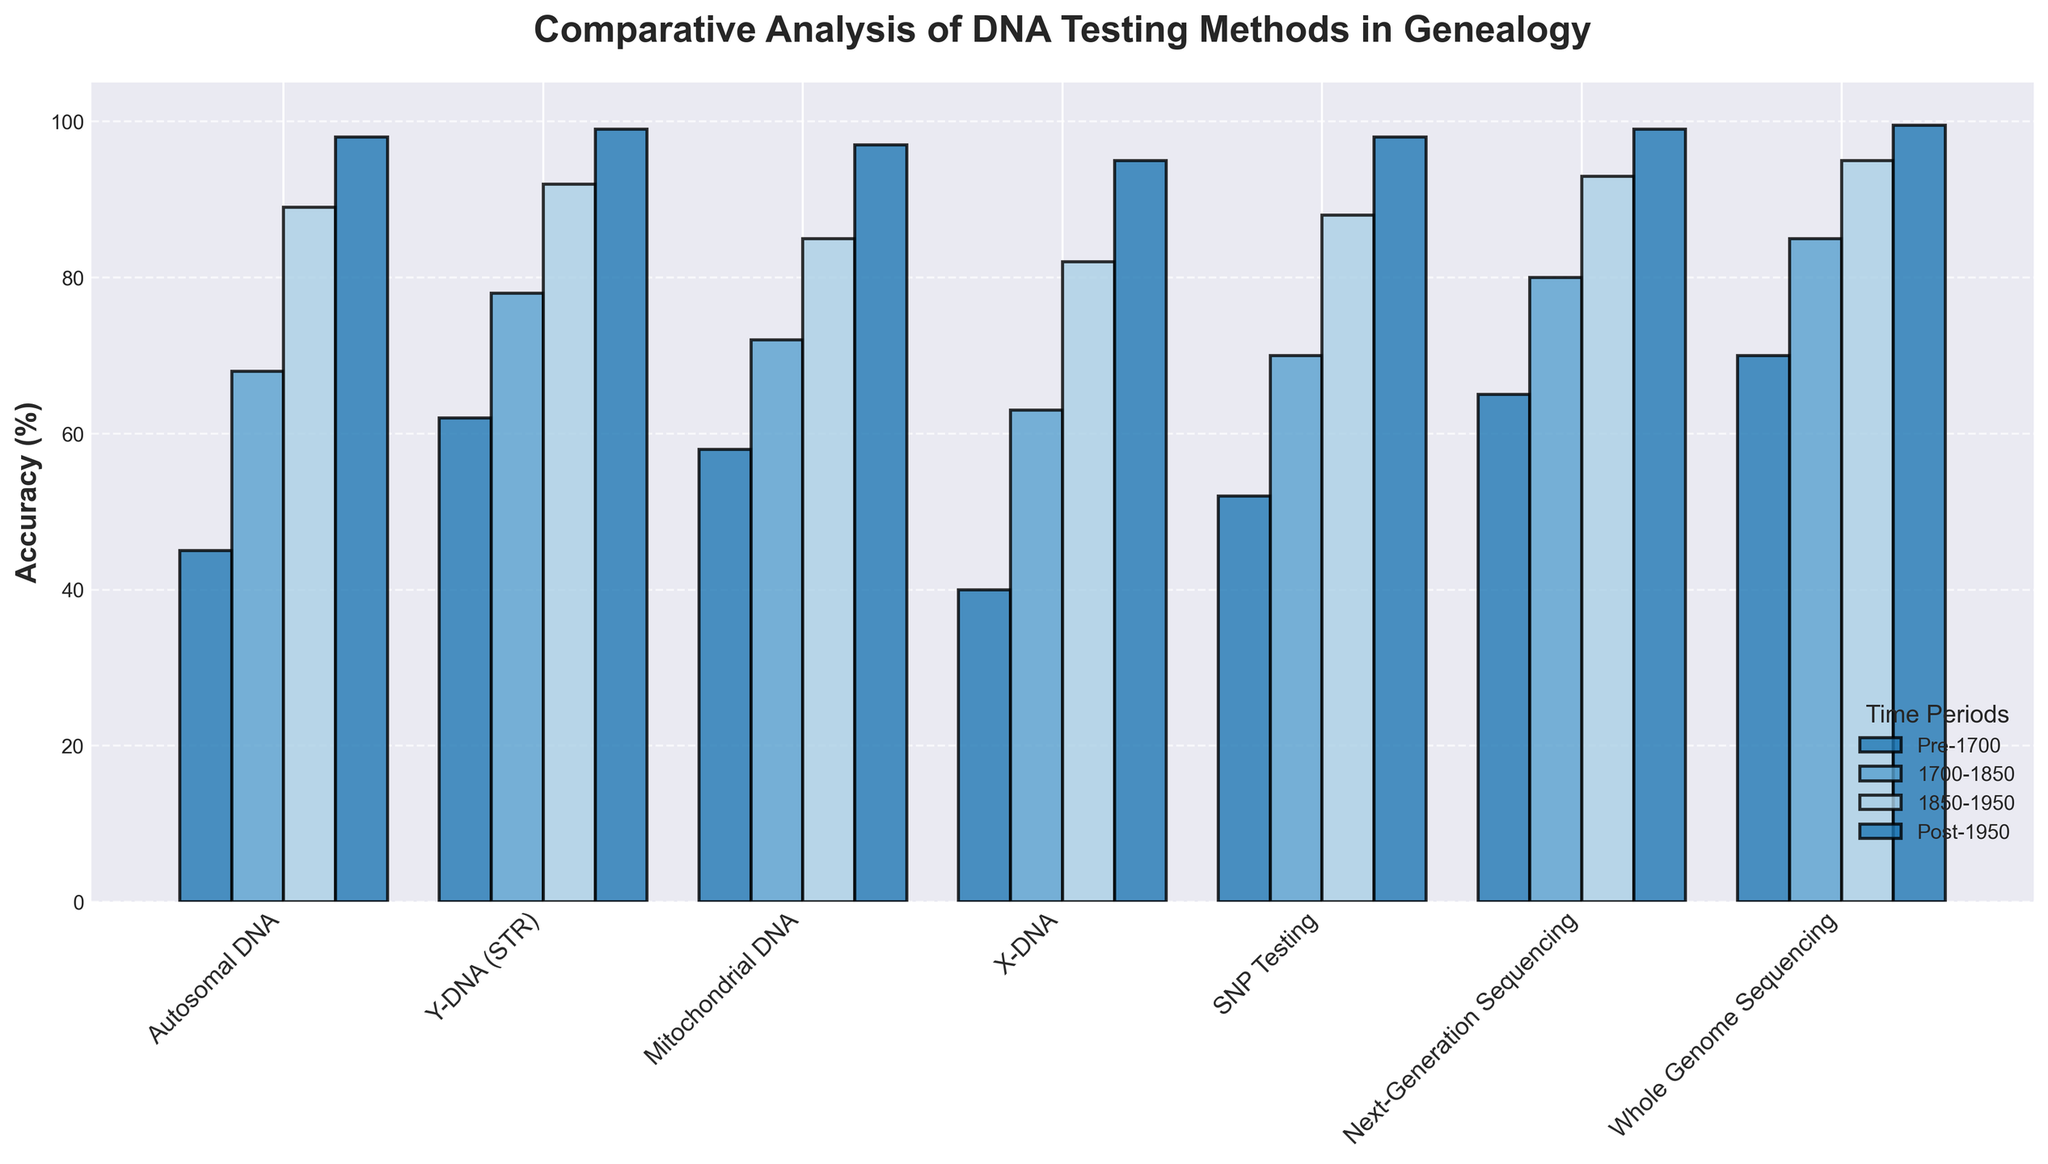What's the average accuracy rate across all periods for Whole Genome Sequencing? Calculate the sum of all accuracy rates for Whole Genome Sequencing (70 + 85 + 95 + 99.5), which equals 349.5. Then, divide by the number of periods (4), giving an average of 349.5 / 4 = 87.375.
Answer: 87.375 Which DNA testing method shows the least increase in accuracy from Pre-1700 to Post-1950? Find the difference in accuracy between Pre-1700 and Post-1950 for each method. The smallest difference corresponds to X-DNA (95 - 40 = 55).
Answer: X-DNA What is the accuracy difference between Y-DNA (STR) and Autosomal DNA for the 1850-1950 period? Subtract the accuracy of Autosomal DNA from Y-DNA (STR) for the 1850-1950 period (92 - 89). The difference is 3.
Answer: 3 Which period shows the highest accuracy rate for Mitochondrial DNA and what is the value? Observing the Mitochondrial DNA accuracies: the Post-1950 period shows the highest accuracy rate of 97%.
Answer: Post-1950, 97% What is the overall trend observed for the accuracy rates of Next-Generation Sequencing across the given time periods? The accuracies for Next-Generation Sequencing show a consistent increase across all periods (65, 80, 93, 99).
Answer: Increasing trend By how much did the accuracy of SNP Testing improve from 1850-1950 to Post-1950? Subtract the accuracy rate of SNP Testing for 1850-1950 from that of Post-1950 (98 - 88). The improvement is 10%.
Answer: 10% Which DNA testing methods achieve an accuracy rate of 99% or higher in the Post-1950 period? Identify the methods with accuracy rates of 99% or above in Post-1950: Y-DNA (STR), Next-Generation Sequencing, and Whole Genome Sequencing meet this criterion.
Answer: Y-DNA (STR), Next-Generation Sequencing, Whole Genome Sequencing Does any testing method have a lower accuracy rate than X-DNA in the 1700-1850 period? Compare each method's accuracy rate in the 1700-1850 period with X-DNA's rate of 63. Autosomal DNA has a lower rate of 62.
Answer: Autosomal DNA 